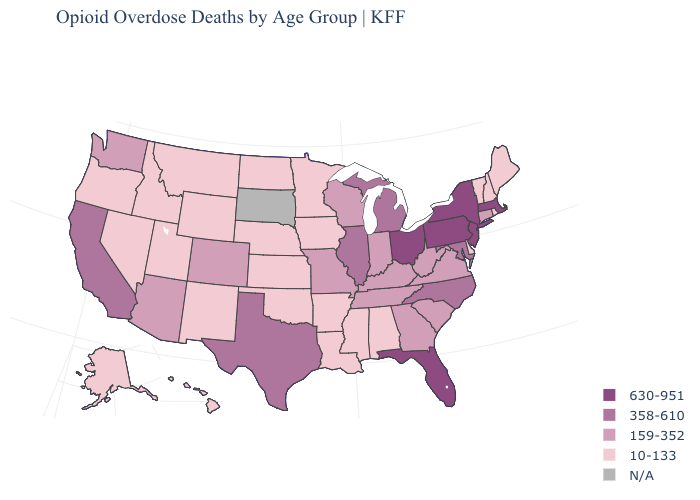Does Iowa have the lowest value in the USA?
Keep it brief. Yes. Does the map have missing data?
Short answer required. Yes. What is the highest value in the USA?
Keep it brief. 630-951. Among the states that border Illinois , does Missouri have the highest value?
Quick response, please. Yes. How many symbols are there in the legend?
Be succinct. 5. Does Washington have the lowest value in the USA?
Write a very short answer. No. Name the states that have a value in the range 159-352?
Keep it brief. Arizona, Colorado, Connecticut, Georgia, Indiana, Kentucky, Missouri, South Carolina, Tennessee, Virginia, Washington, West Virginia, Wisconsin. Name the states that have a value in the range N/A?
Write a very short answer. South Dakota. Does the map have missing data?
Be succinct. Yes. Does Alabama have the lowest value in the USA?
Concise answer only. Yes. What is the value of Minnesota?
Give a very brief answer. 10-133. Does the first symbol in the legend represent the smallest category?
Be succinct. No. 